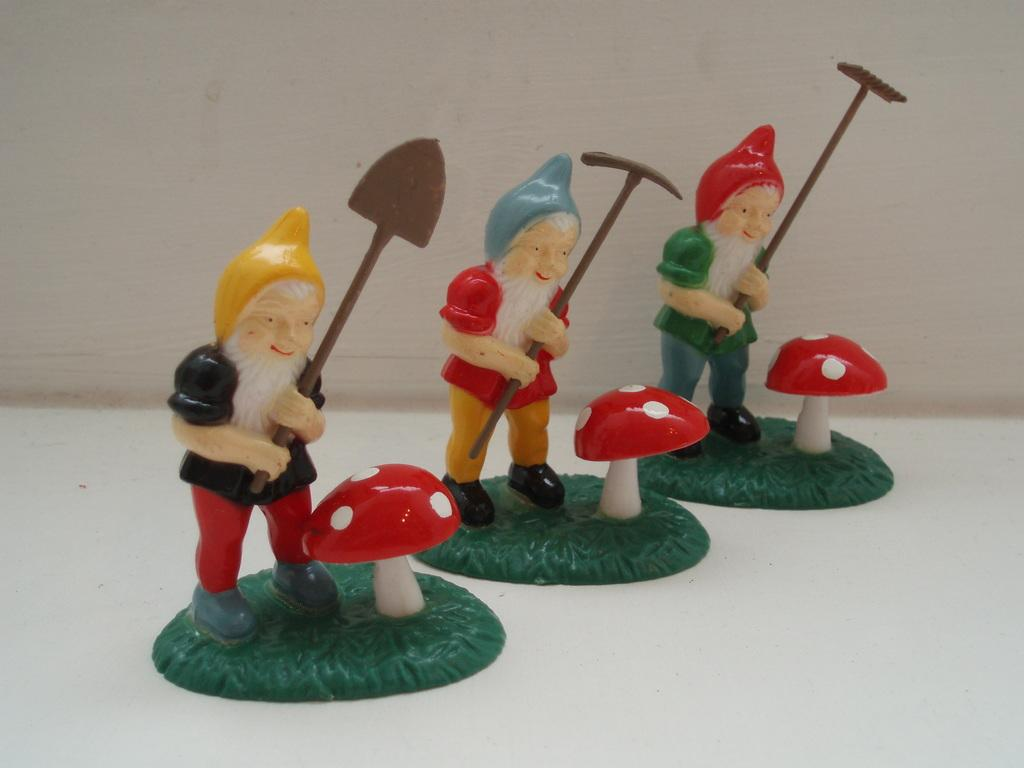What type of toys are present in the image? The toys in the image are of persons holding tools. How are the toys interacting with their tools? The toys are depicted with their hands, suggesting they are using the tools. What other objects can be seen in the image besides the toys? There are mushrooms in the image. Where are the toys and mushrooms located? They are on a floor. What can be seen in the background of the image? There is a wall visible in the background of the image. What type of feast is being prepared on the floor in the image? There is no feast being prepared in the image; it features toys of persons holding tools and mushrooms on a floor. Can you tell me how many dinosaurs are present in the image? There are no dinosaurs present in the image. 